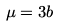<formula> <loc_0><loc_0><loc_500><loc_500>\mu = 3 b</formula> 